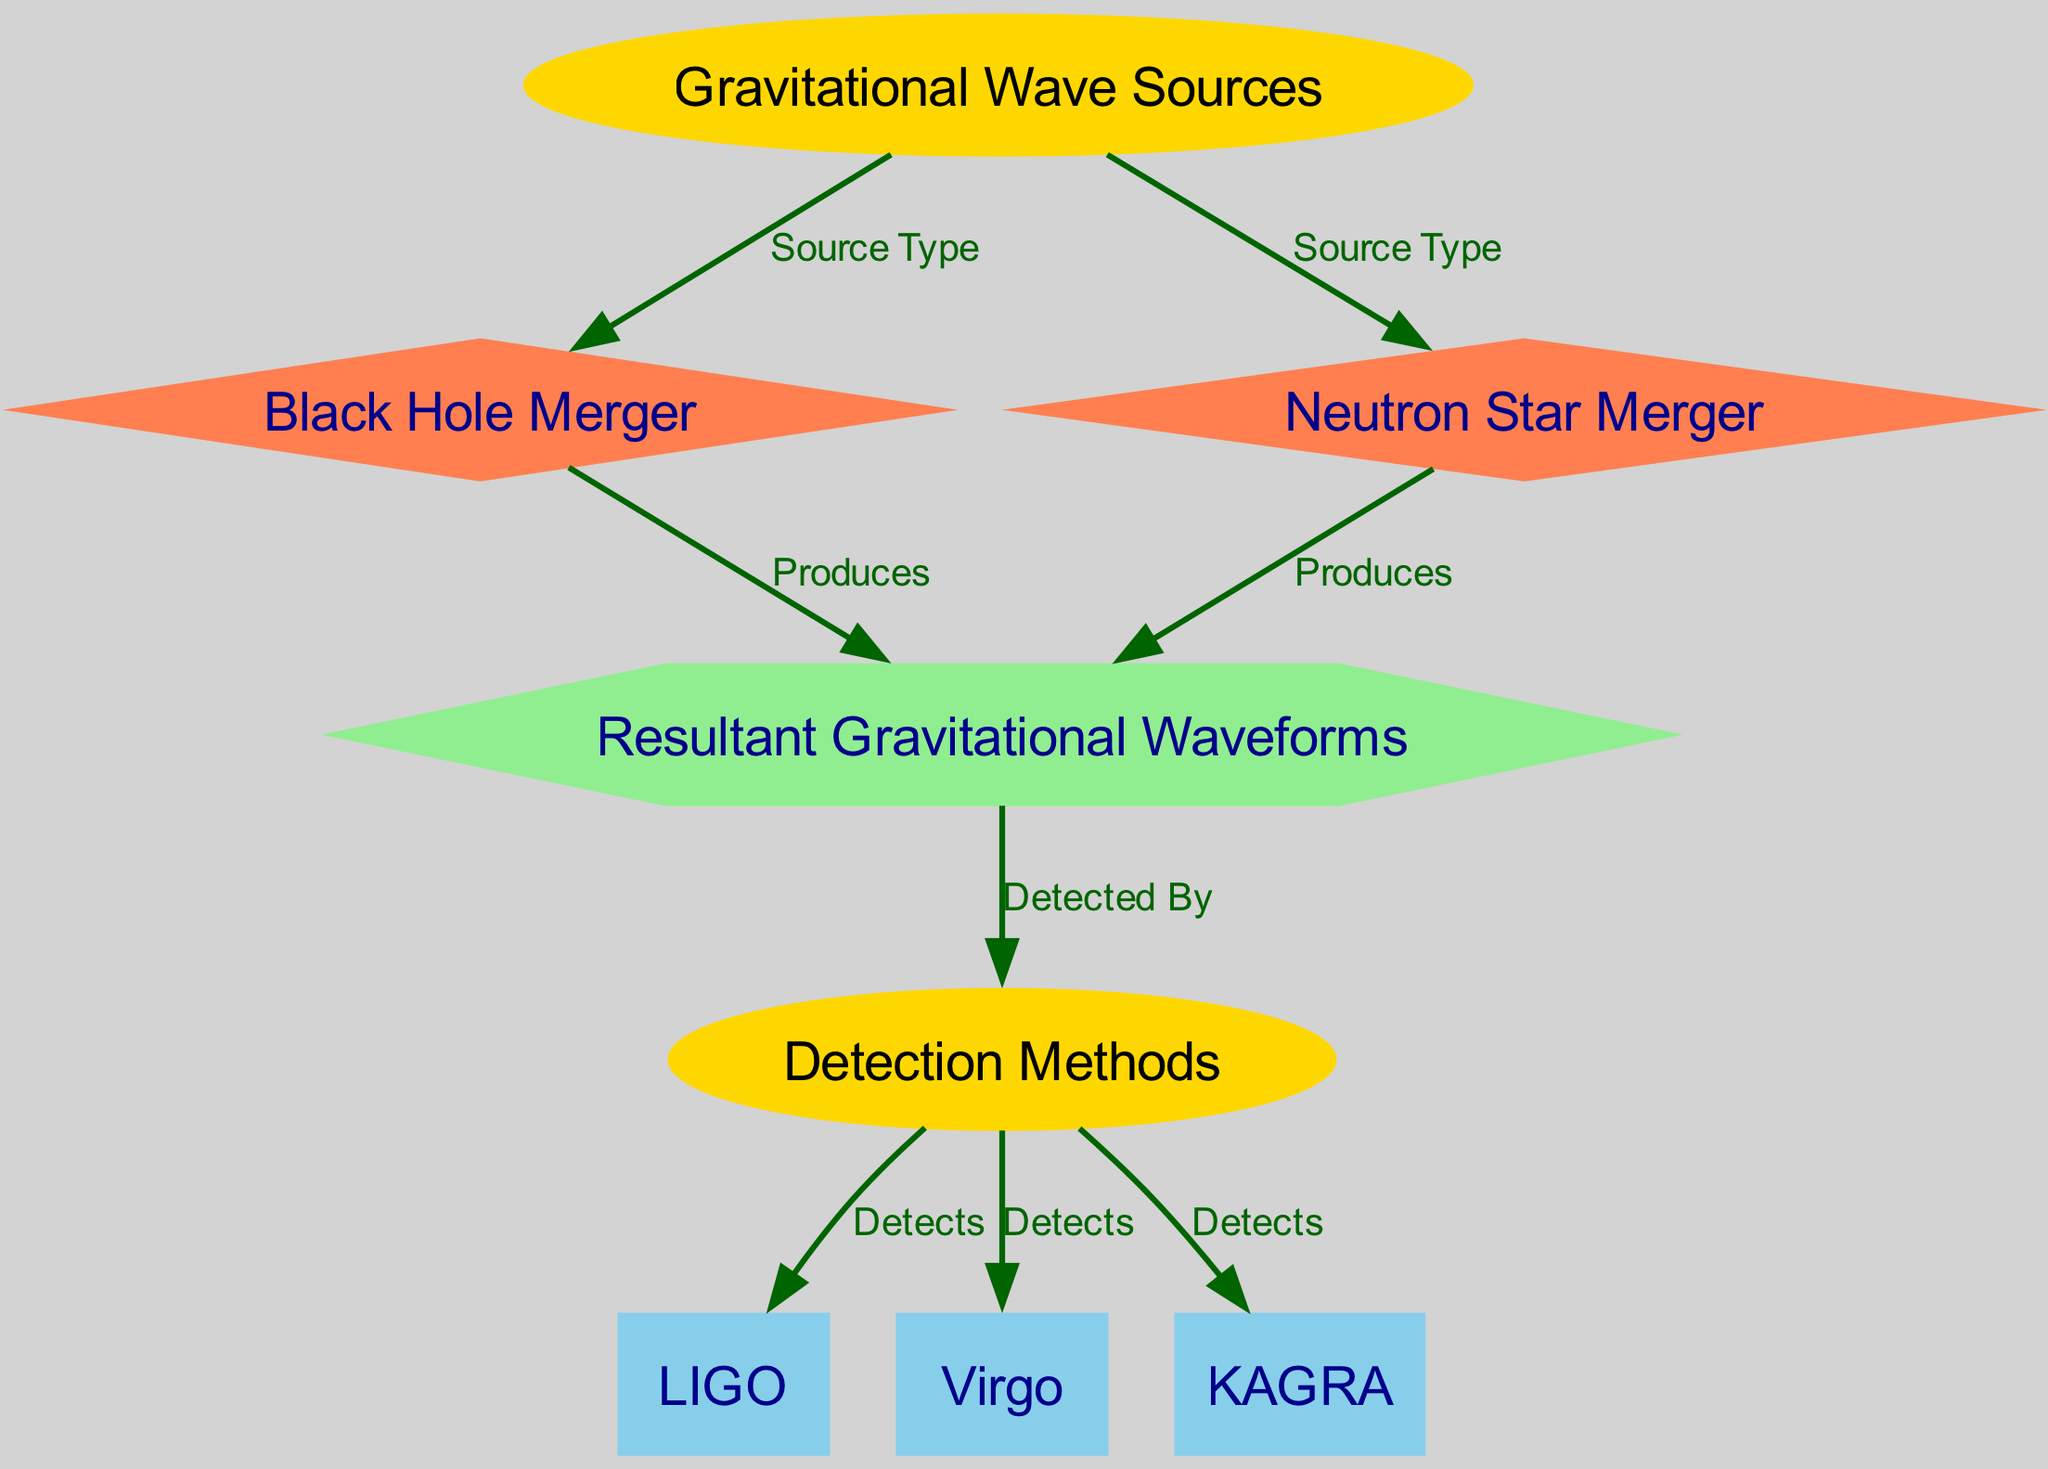What are the two types of gravitational wave sources? The diagram lists two distinct types of gravitational wave sources: Black Hole Merger and Neutron Star Merger connected to "Gravitational Wave Sources" with "Source Type."
Answer: Black Hole Merger, Neutron Star Merger How many detection methods are depicted in the diagram? The diagram has three detection methods connected to "Detection Methods": LIGO, Virgo, and KAGRA. Counting these nodes gives a total of three.
Answer: 3 What node shape represents the resultant gravitational waveforms? The "Resultant Gravitational Waveforms" node is depicted in the diagram as a hexagon, which is visually distinctive compared to the other node shapes.
Answer: Hexagon Which detection method is connected to the resultant gravitational waveforms? In the diagram, the "Resultant Gravitational Waveforms" node has an edge to "Detection Methods," indicating that it is detected by one or more methods shown in that category.
Answer: Detection Methods What produces the resultant gravitational waveforms? The diagram indicates two sources that produce resultant gravitational waveforms: Black Hole Merger and Neutron Star Merger. This is illustrated through edges connecting these nodes to "Resultant Gravitational Waveforms."
Answer: Black Hole Merger, Neutron Star Merger Which detection method is illustrated as detecting gravitational waves in the diagram? The diagram displays edges from "Detection Methods" that connect to LIGO, Virgo, and KAGRA, all indicating they detect the waves. Thus, these methods are illustrated in the diagram as capable of detection.
Answer: LIGO, Virgo, KAGRA Is "Gravitational Wave Sources" an ellipse or a rectangle? The "Gravitational Wave Sources" node is specified in the diagram as an ellipse, as per the distinct shapes assigned to different types of nodes.
Answer: Ellipse What is the relationship between neutron star mergers and gravitational waveforms? The diagram explicitly shows an edge labeled "Produces" connecting "Neutron Star Merger" to "Resultant Gravitational Waveforms," demonstrating that neutron star mergers are a source of these waveforms.
Answer: Produces 